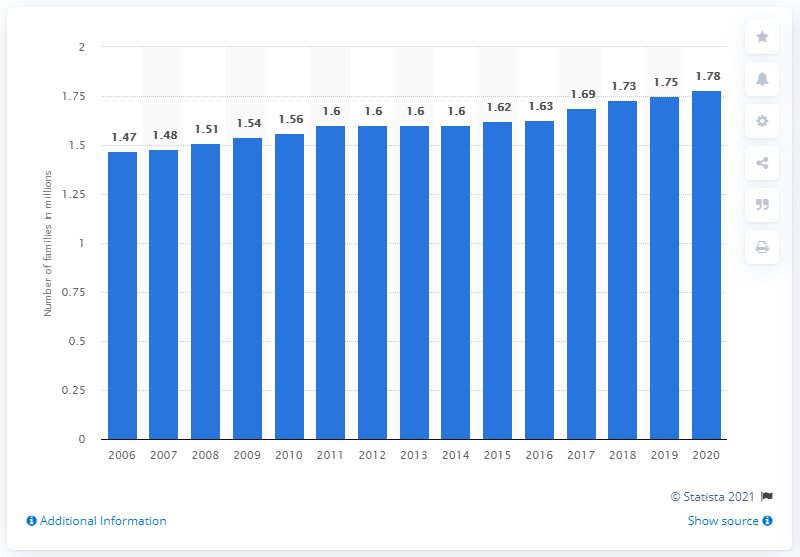Identify some key points in this picture. As of 2020, it was estimated that there were 1.78 million single parent families living in Canada. In 2010, there were approximately 1.56 million single parent families in Canada. In 2010, the total number of single parent families in Canada was 1.56 million. 